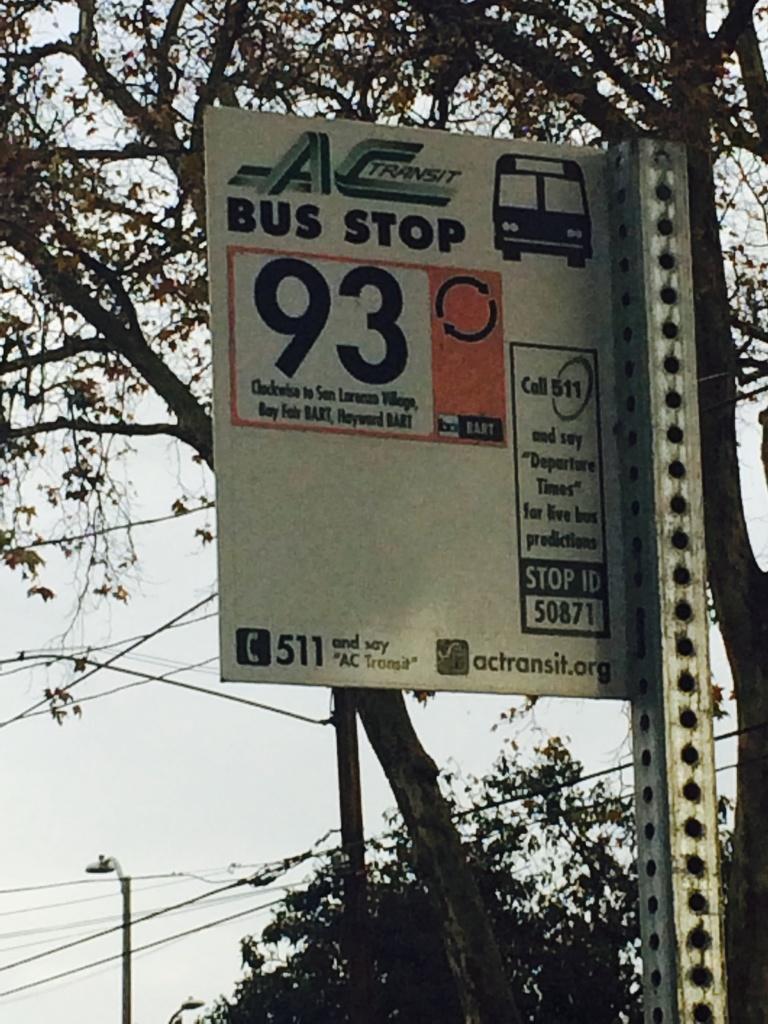Can you describe this image briefly? Here in the front we can see a bus stop board present on a pole over there and behind it we can see trees present here and there and we can see light posts and wires present over there. 